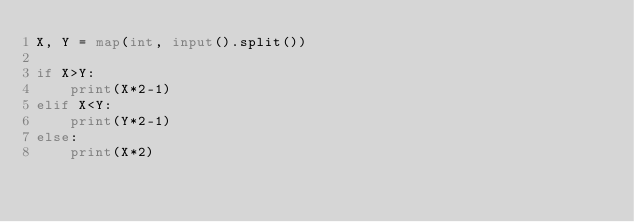<code> <loc_0><loc_0><loc_500><loc_500><_Python_>X, Y = map(int, input().split())

if X>Y:
    print(X*2-1)
elif X<Y:
    print(Y*2-1)
else:
    print(X*2)</code> 